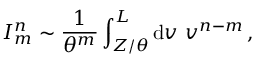<formula> <loc_0><loc_0><loc_500><loc_500>I _ { m } ^ { n } \sim \frac { 1 } { \theta ^ { m } } \int _ { Z / \theta } ^ { L } d v \ v ^ { n - m } \, ,</formula> 